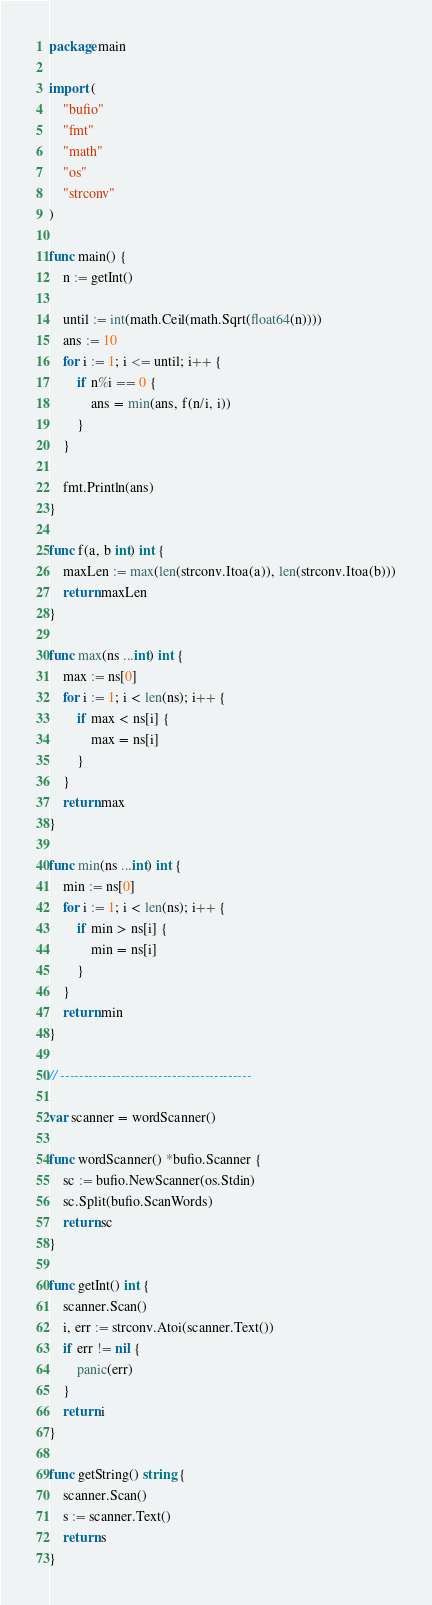<code> <loc_0><loc_0><loc_500><loc_500><_Go_>package main

import (
	"bufio"
	"fmt"
	"math"
	"os"
	"strconv"
)

func main() {
	n := getInt()

	until := int(math.Ceil(math.Sqrt(float64(n))))
	ans := 10
	for i := 1; i <= until; i++ {
		if n%i == 0 {
			ans = min(ans, f(n/i, i))
		}
	}

	fmt.Println(ans)
}

func f(a, b int) int {
	maxLen := max(len(strconv.Itoa(a)), len(strconv.Itoa(b)))
	return maxLen
}

func max(ns ...int) int {
	max := ns[0]
	for i := 1; i < len(ns); i++ {
		if max < ns[i] {
			max = ns[i]
		}
	}
	return max
}

func min(ns ...int) int {
	min := ns[0]
	for i := 1; i < len(ns); i++ {
		if min > ns[i] {
			min = ns[i]
		}
	}
	return min
}

// -----------------------------------------

var scanner = wordScanner()

func wordScanner() *bufio.Scanner {
	sc := bufio.NewScanner(os.Stdin)
	sc.Split(bufio.ScanWords)
	return sc
}

func getInt() int {
	scanner.Scan()
	i, err := strconv.Atoi(scanner.Text())
	if err != nil {
		panic(err)
	}
	return i
}

func getString() string {
	scanner.Scan()
	s := scanner.Text()
	return s
}
</code> 